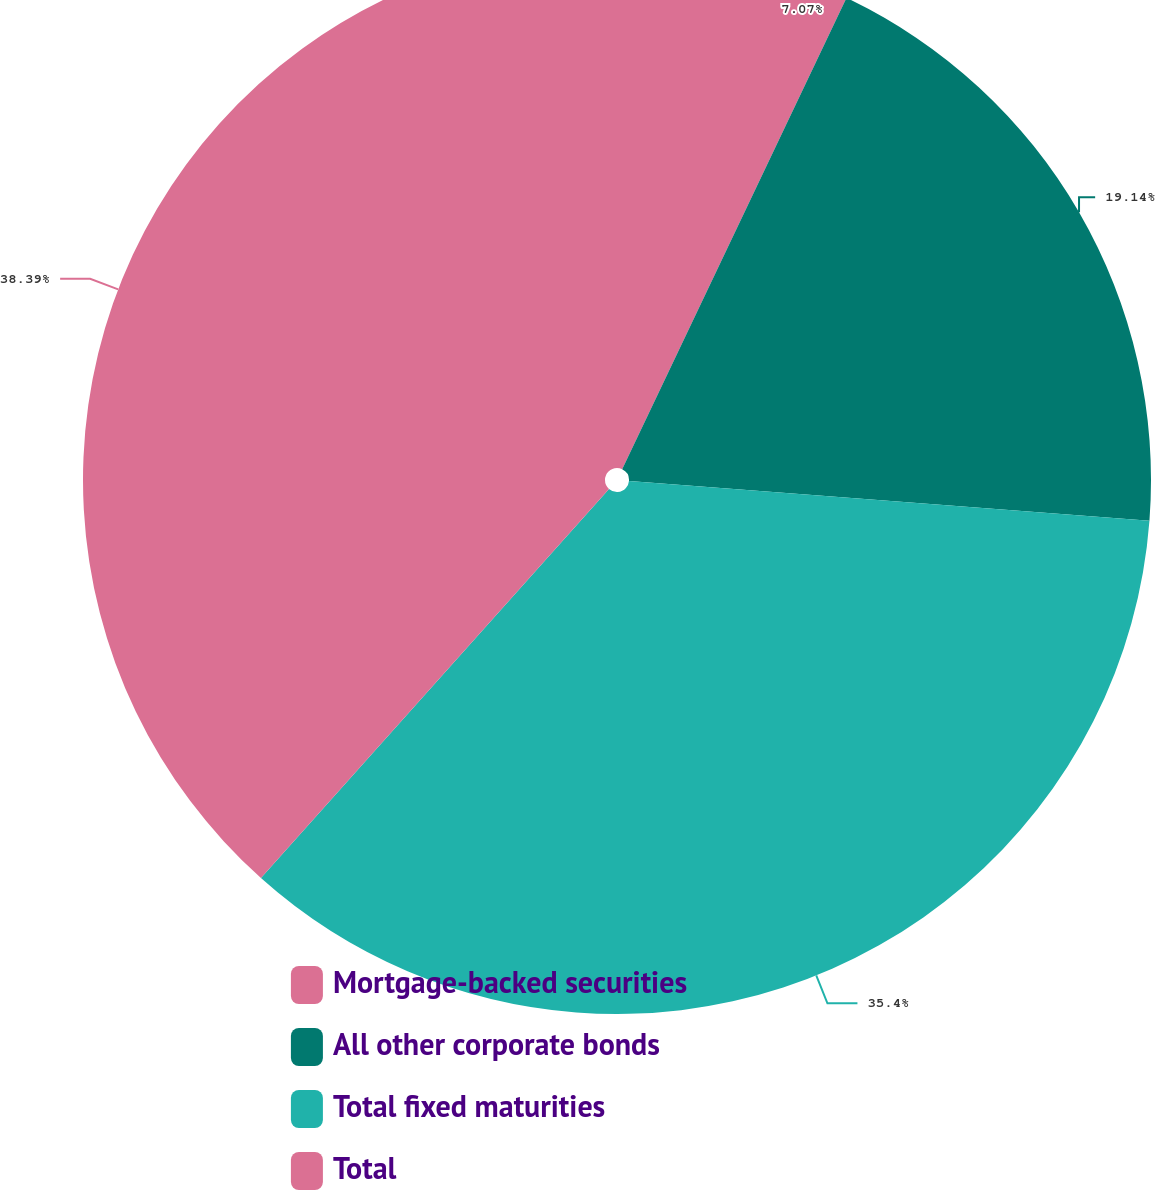<chart> <loc_0><loc_0><loc_500><loc_500><pie_chart><fcel>Mortgage-backed securities<fcel>All other corporate bonds<fcel>Total fixed maturities<fcel>Total<nl><fcel>7.07%<fcel>19.14%<fcel>35.4%<fcel>38.38%<nl></chart> 